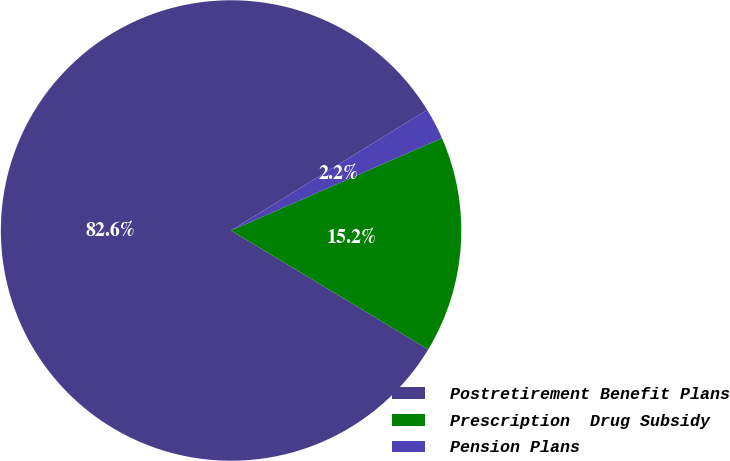Convert chart to OTSL. <chart><loc_0><loc_0><loc_500><loc_500><pie_chart><fcel>Postretirement Benefit Plans<fcel>Prescription  Drug Subsidy<fcel>Pension Plans<nl><fcel>82.58%<fcel>15.21%<fcel>2.21%<nl></chart> 